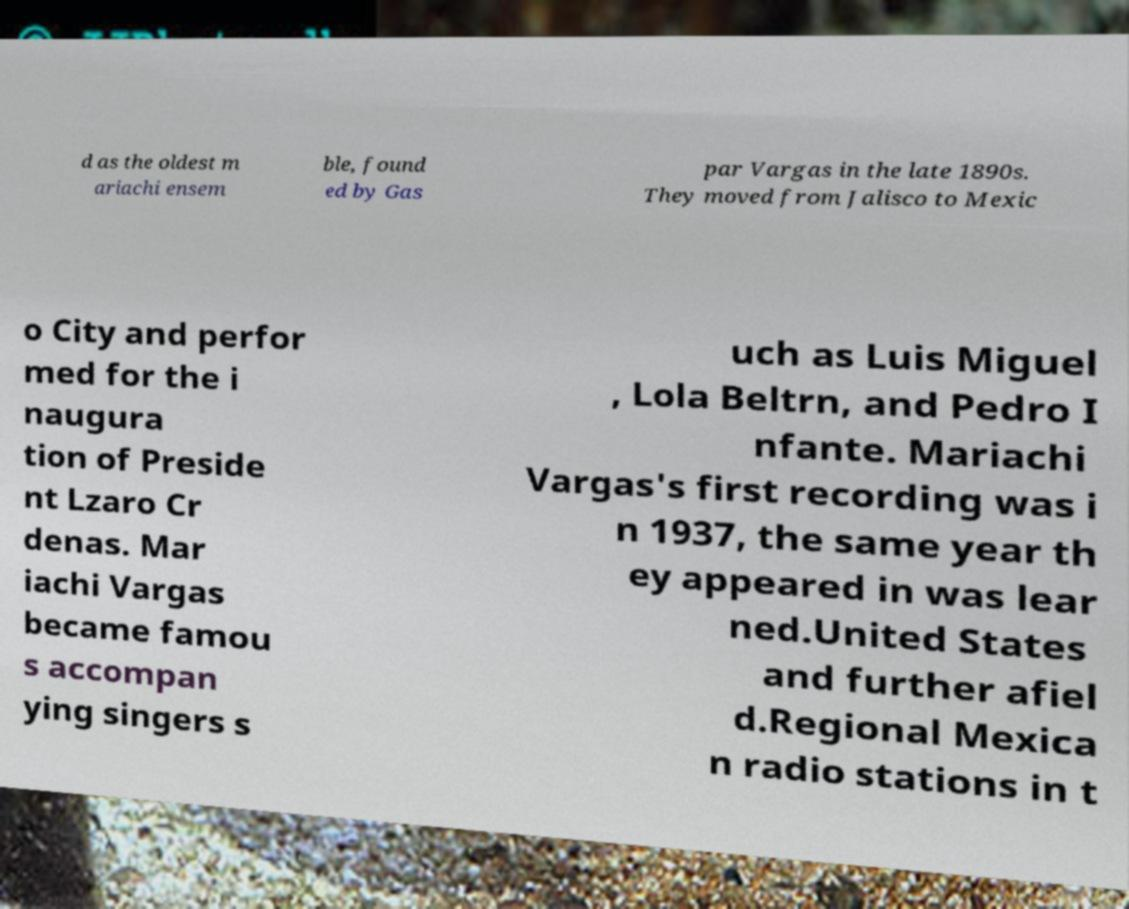Can you accurately transcribe the text from the provided image for me? d as the oldest m ariachi ensem ble, found ed by Gas par Vargas in the late 1890s. They moved from Jalisco to Mexic o City and perfor med for the i naugura tion of Preside nt Lzaro Cr denas. Mar iachi Vargas became famou s accompan ying singers s uch as Luis Miguel , Lola Beltrn, and Pedro I nfante. Mariachi Vargas's first recording was i n 1937, the same year th ey appeared in was lear ned.United States and further afiel d.Regional Mexica n radio stations in t 